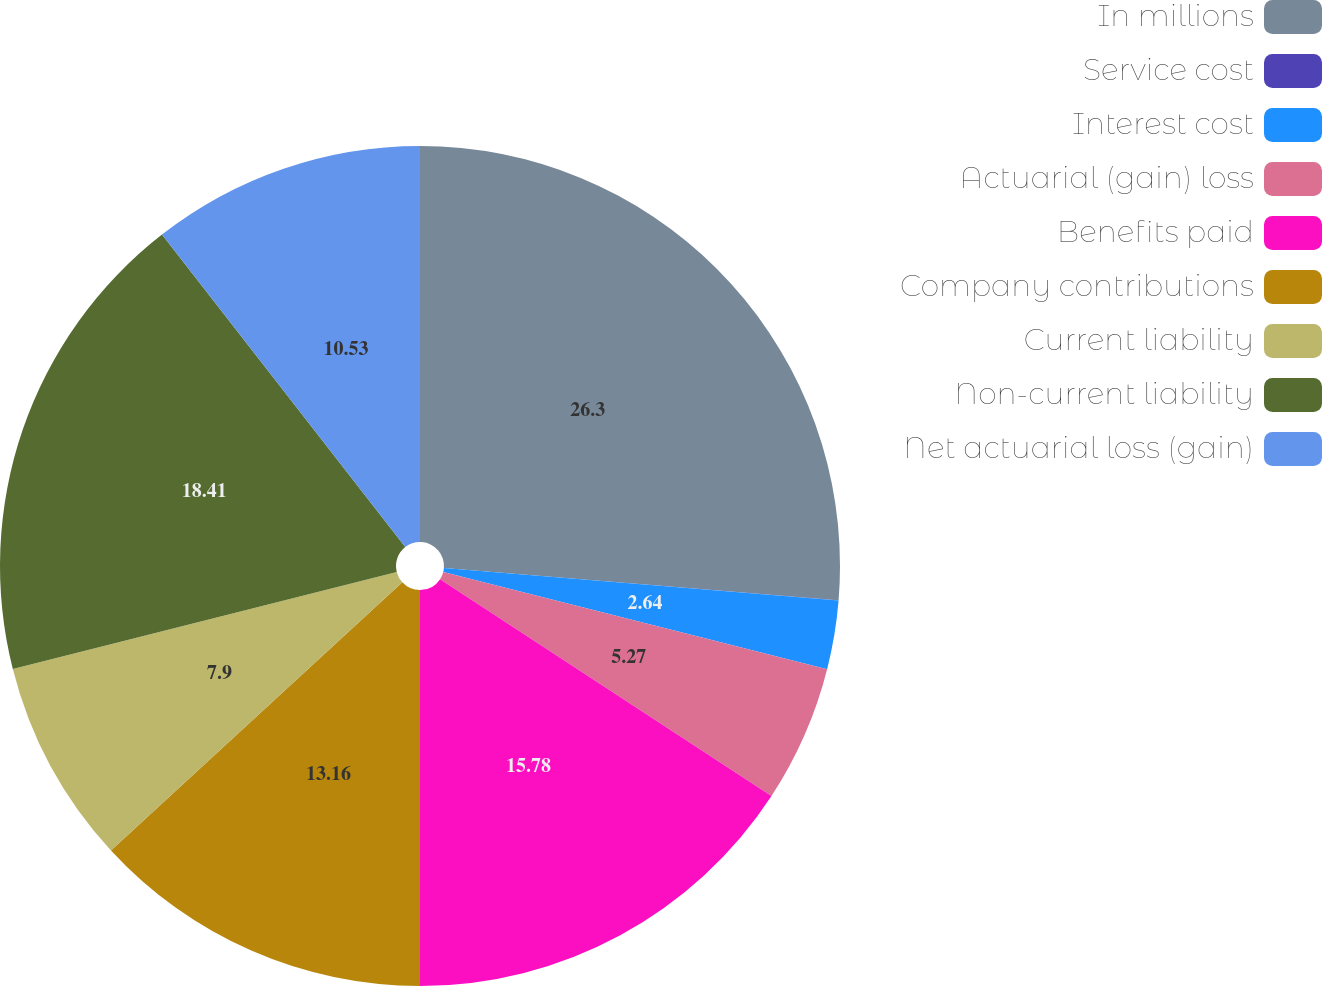Convert chart to OTSL. <chart><loc_0><loc_0><loc_500><loc_500><pie_chart><fcel>In millions<fcel>Service cost<fcel>Interest cost<fcel>Actuarial (gain) loss<fcel>Benefits paid<fcel>Company contributions<fcel>Current liability<fcel>Non-current liability<fcel>Net actuarial loss (gain)<nl><fcel>26.3%<fcel>0.01%<fcel>2.64%<fcel>5.27%<fcel>15.78%<fcel>13.16%<fcel>7.9%<fcel>18.41%<fcel>10.53%<nl></chart> 